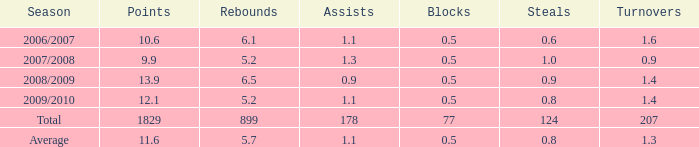How many blocks exist when the rebounds are less than 0.0. 